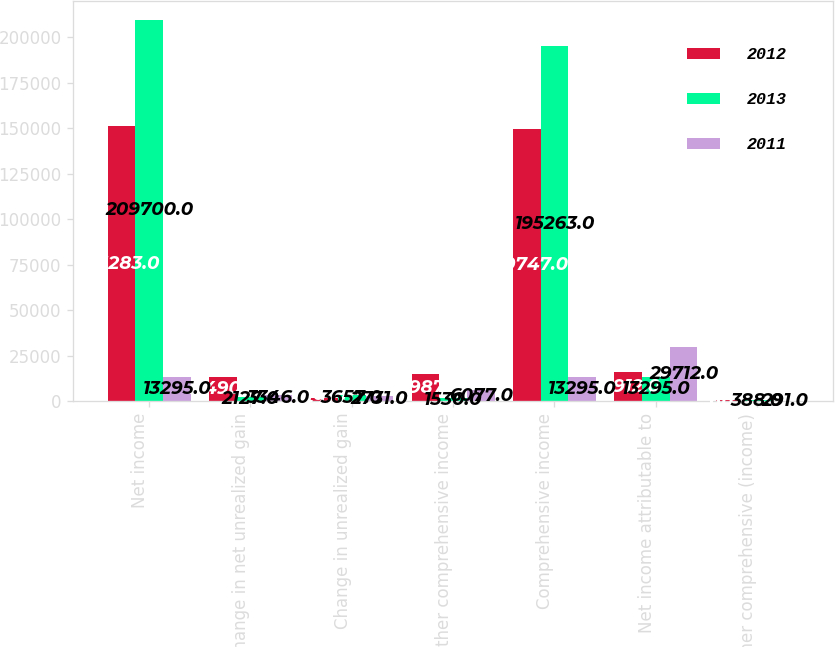<chart> <loc_0><loc_0><loc_500><loc_500><stacked_bar_chart><ecel><fcel>Net income<fcel>Change in net unrealized gain<fcel>Change in unrealized gain<fcel>Other comprehensive income<fcel>Comprehensive income<fcel>Net income attributable to<fcel>Other comprehensive (income)<nl><fcel>2012<fcel>151283<fcel>13490<fcel>1497<fcel>14987<fcel>149747<fcel>15912<fcel>611<nl><fcel>2013<fcel>209700<fcel>2127<fcel>3657<fcel>1530<fcel>195263<fcel>13295<fcel>388<nl><fcel>2011<fcel>13295<fcel>3346<fcel>2731<fcel>6077<fcel>13295<fcel>29712<fcel>291<nl></chart> 